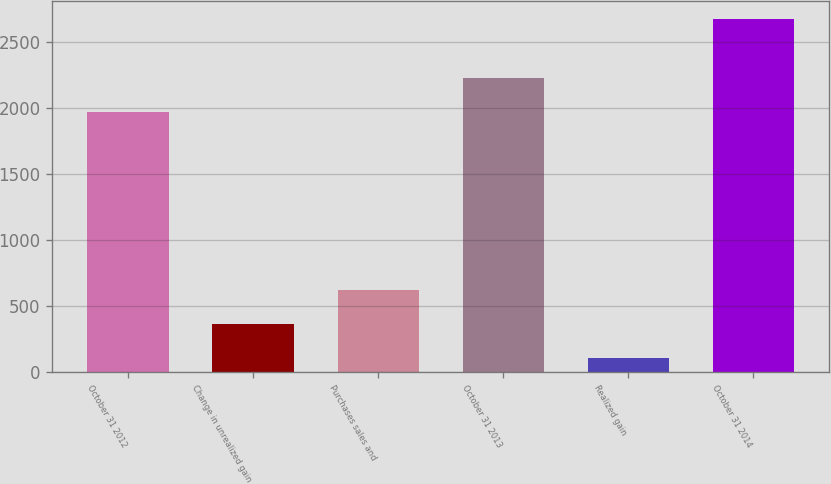<chart> <loc_0><loc_0><loc_500><loc_500><bar_chart><fcel>October 31 2012<fcel>Change in unrealized gain<fcel>Purchases sales and<fcel>October 31 2013<fcel>Realized gain<fcel>October 31 2014<nl><fcel>1969<fcel>362.2<fcel>619.4<fcel>2226.2<fcel>105<fcel>2677<nl></chart> 